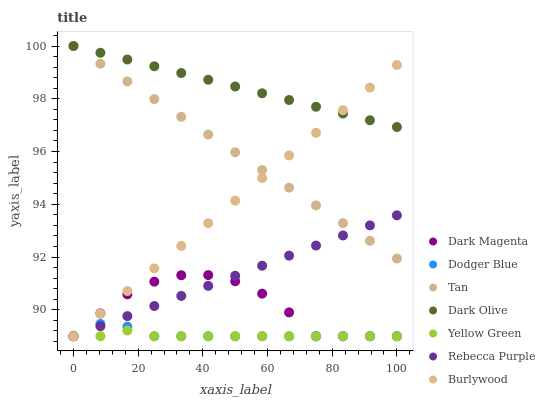Does Yellow Green have the minimum area under the curve?
Answer yes or no. Yes. Does Dark Olive have the maximum area under the curve?
Answer yes or no. Yes. Does Burlywood have the minimum area under the curve?
Answer yes or no. No. Does Burlywood have the maximum area under the curve?
Answer yes or no. No. Is Rebecca Purple the smoothest?
Answer yes or no. Yes. Is Dark Magenta the roughest?
Answer yes or no. Yes. Is Burlywood the smoothest?
Answer yes or no. No. Is Burlywood the roughest?
Answer yes or no. No. Does Dark Magenta have the lowest value?
Answer yes or no. Yes. Does Dark Olive have the lowest value?
Answer yes or no. No. Does Tan have the highest value?
Answer yes or no. Yes. Does Burlywood have the highest value?
Answer yes or no. No. Is Dodger Blue less than Dark Olive?
Answer yes or no. Yes. Is Tan greater than Yellow Green?
Answer yes or no. Yes. Does Rebecca Purple intersect Dark Magenta?
Answer yes or no. Yes. Is Rebecca Purple less than Dark Magenta?
Answer yes or no. No. Is Rebecca Purple greater than Dark Magenta?
Answer yes or no. No. Does Dodger Blue intersect Dark Olive?
Answer yes or no. No. 